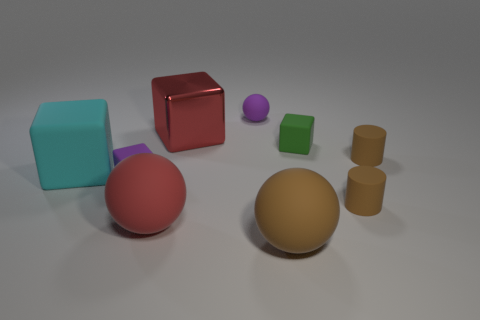Add 1 cyan blocks. How many objects exist? 10 Subtract all tiny purple rubber balls. How many balls are left? 2 Subtract all balls. How many objects are left? 6 Subtract 1 spheres. How many spheres are left? 2 Add 3 tiny green cubes. How many tiny green cubes exist? 4 Subtract all red spheres. How many spheres are left? 2 Subtract 0 yellow cylinders. How many objects are left? 9 Subtract all green blocks. Subtract all brown balls. How many blocks are left? 3 Subtract all gray cylinders. How many purple spheres are left? 1 Subtract all large blue metal cylinders. Subtract all brown rubber cylinders. How many objects are left? 7 